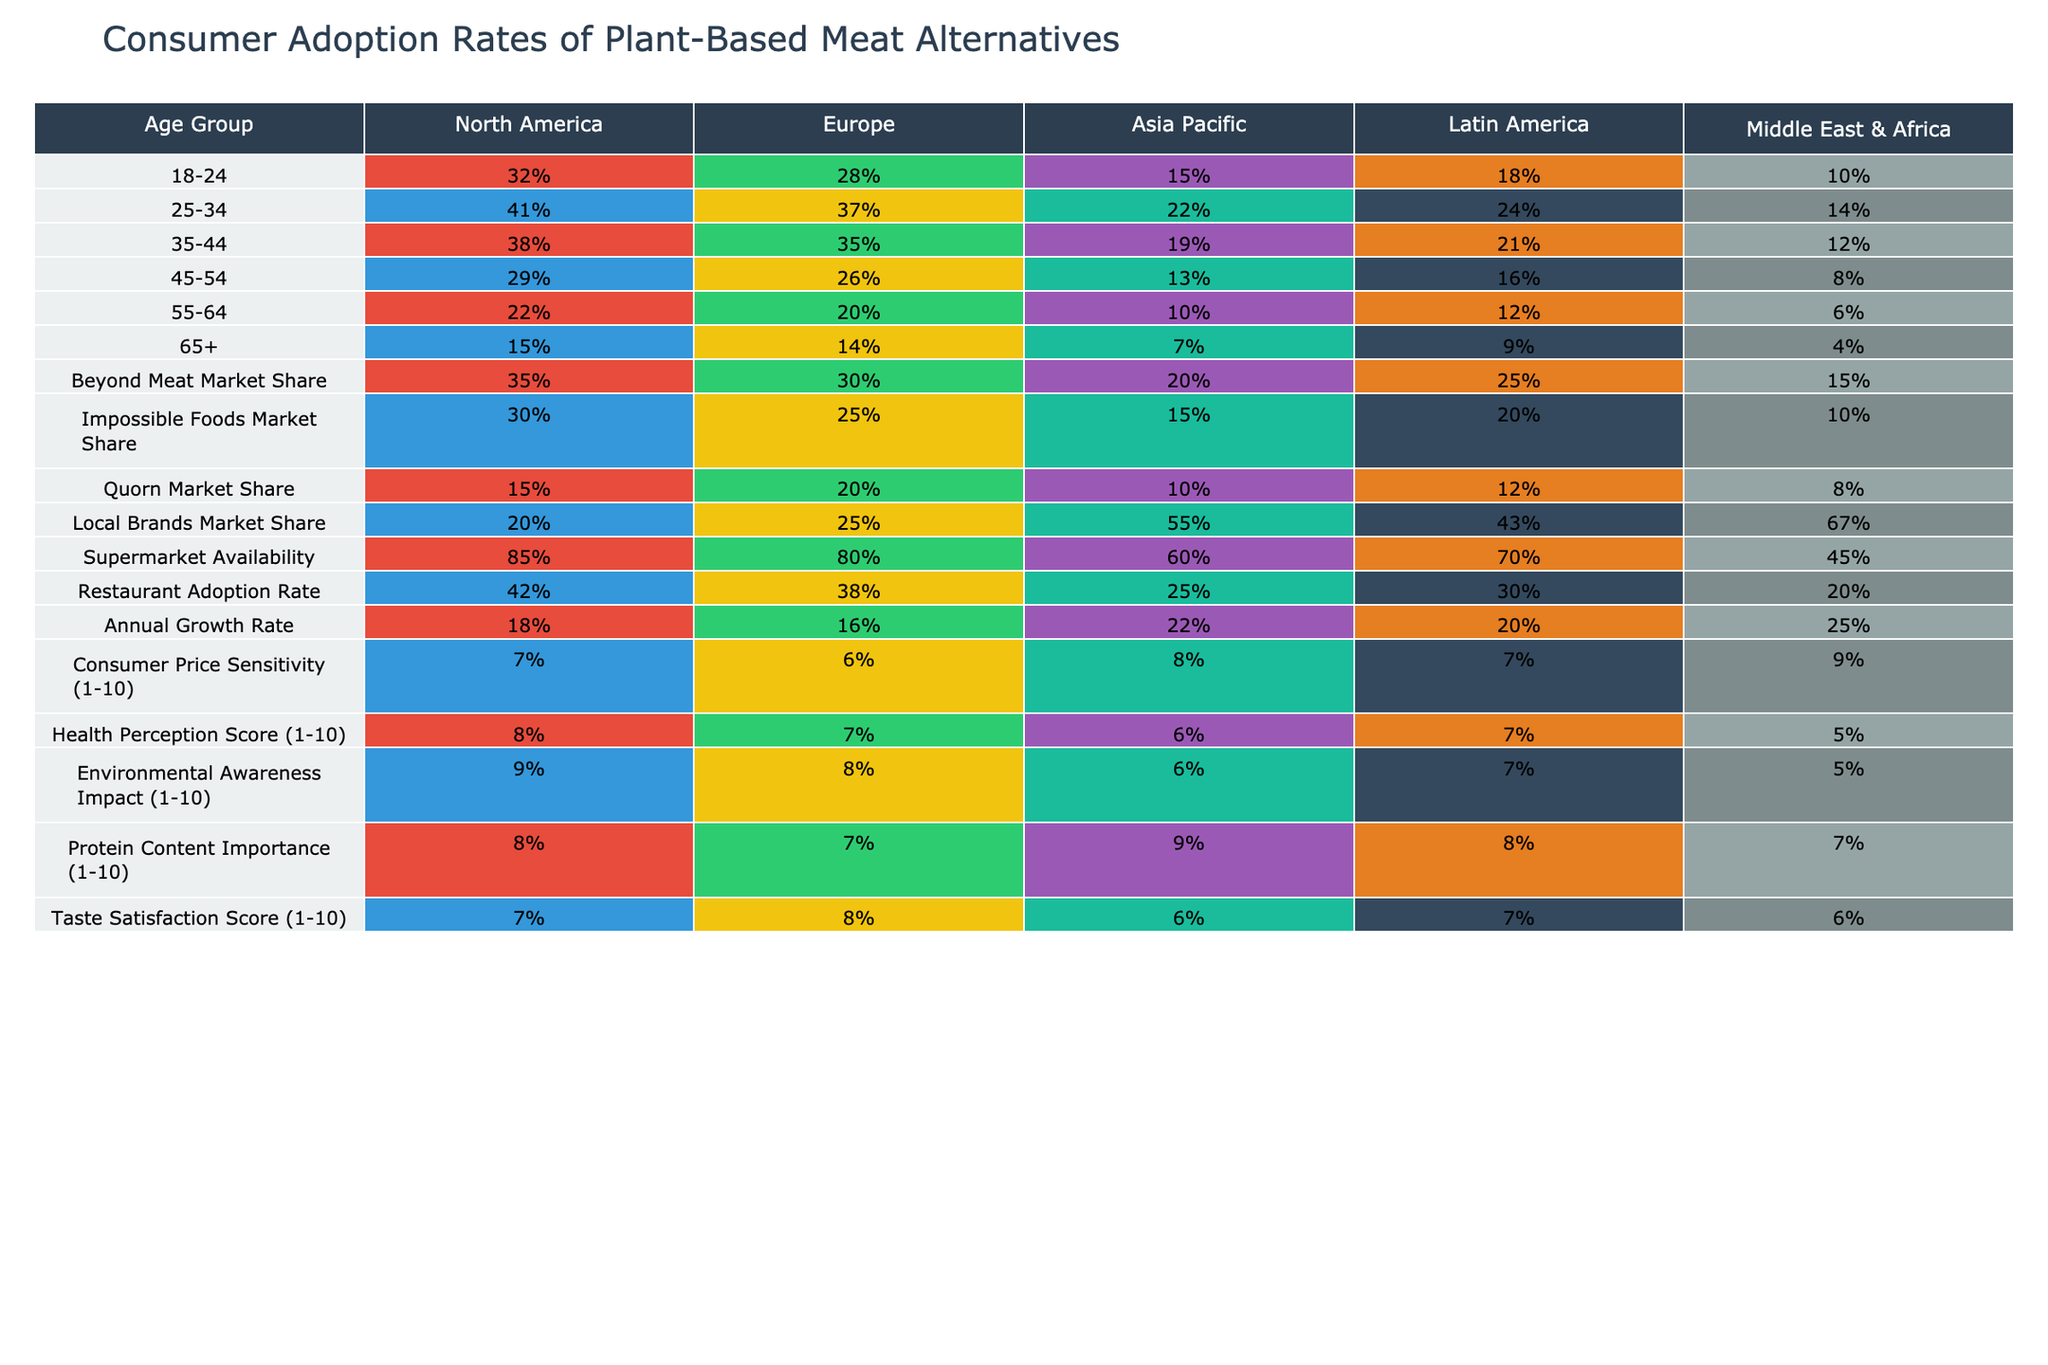What is the consumer adoption rate of plant-based meat alternatives for the 18-24 age group in North America? The table shows that the adoption rate for the 18-24 age group in North America is 32%.
Answer: 32% What is the difference in adoption rates between the 25-34 age group in Europe and the 45-54 age group in Asia Pacific? In Europe, the adoption rate for the 25-34 age group is 37%, and for the 45-54 age group in Asia Pacific, it is 13%. The difference is 37% - 13% = 24%.
Answer: 24% Is the local brands market share higher in Latin America compared to the Middle East & Africa? The local brands market share in Latin America is 43%, while in the Middle East & Africa, it is 67%. Since 43% is less than 67%, the statement is false.
Answer: No What age group shows the highest level of consumer adoption of plant-based meat alternatives in Europe? The table indicates that the 25-34 age group has an adoption rate of 37%, the highest among the provided age groups in Europe.
Answer: 25-34 What is the overall consumer adoption rate for the 65+ age group across all regions? To find the overall adoption rate for the 65+ age group across all regions, we need to average the rates: (15% + 14% + 7% + 9% + 4%) / 5 = 49% / 5 = 9.8%.
Answer: 9.8% What region has the highest supermarket availability for plant-based meat alternatives? The table shows that North America has a supermarket availability rate of 85%, which is the highest compared to other regions.
Answer: North America How much lower is the restaurant adoption rate in Asia Pacific compared to North America? The restaurant adoption rate in North America is 42%, and in Asia Pacific, it is 25%. The difference is calculated as 42% - 25% = 17%.
Answer: 17% Does consumer price sensitivity have the highest score in Asia Pacific or the Middle East & Africa? The consumer price sensitivity score is 8 in Asia Pacific and 9 in the Middle East & Africa. Since 9 is higher than 8, the statement is false.
Answer: No Which age group in Latin America has the highest consumer adoption rate of plant-based meat alternatives? The highest adoption rate in Latin America is for the 25-34 age group at 24%.
Answer: 25-34 By what percentage is the consumer adoption rate in Europe for the 35-44 age group higher than that of the 55-64 age group in the same region? In Europe, the adoption rate for the 35-44 age group is 35% and for the 55-64 age group it is 20%. The difference is 35% - 20% = 15%.
Answer: 15% Which region has the lowest health perception score for plant-based meat alternatives? The table shows that the Middle East & Africa has the lowest health perception score of 5.
Answer: Middle East & Africa 